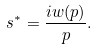Convert formula to latex. <formula><loc_0><loc_0><loc_500><loc_500>s ^ { * } = \frac { i w ( p ) } { p } .</formula> 